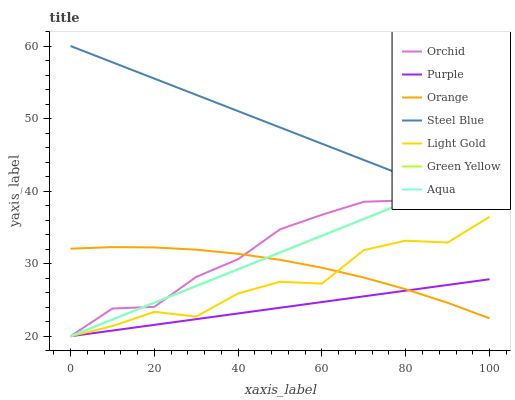Does Purple have the minimum area under the curve?
Answer yes or no. Yes. Does Steel Blue have the maximum area under the curve?
Answer yes or no. Yes. Does Aqua have the minimum area under the curve?
Answer yes or no. No. Does Aqua have the maximum area under the curve?
Answer yes or no. No. Is Steel Blue the smoothest?
Answer yes or no. Yes. Is Orchid the roughest?
Answer yes or no. Yes. Is Aqua the smoothest?
Answer yes or no. No. Is Aqua the roughest?
Answer yes or no. No. Does Purple have the lowest value?
Answer yes or no. Yes. Does Steel Blue have the lowest value?
Answer yes or no. No. Does Steel Blue have the highest value?
Answer yes or no. Yes. Does Aqua have the highest value?
Answer yes or no. No. Is Purple less than Steel Blue?
Answer yes or no. Yes. Is Steel Blue greater than Purple?
Answer yes or no. Yes. Does Green Yellow intersect Orange?
Answer yes or no. Yes. Is Green Yellow less than Orange?
Answer yes or no. No. Is Green Yellow greater than Orange?
Answer yes or no. No. Does Purple intersect Steel Blue?
Answer yes or no. No. 